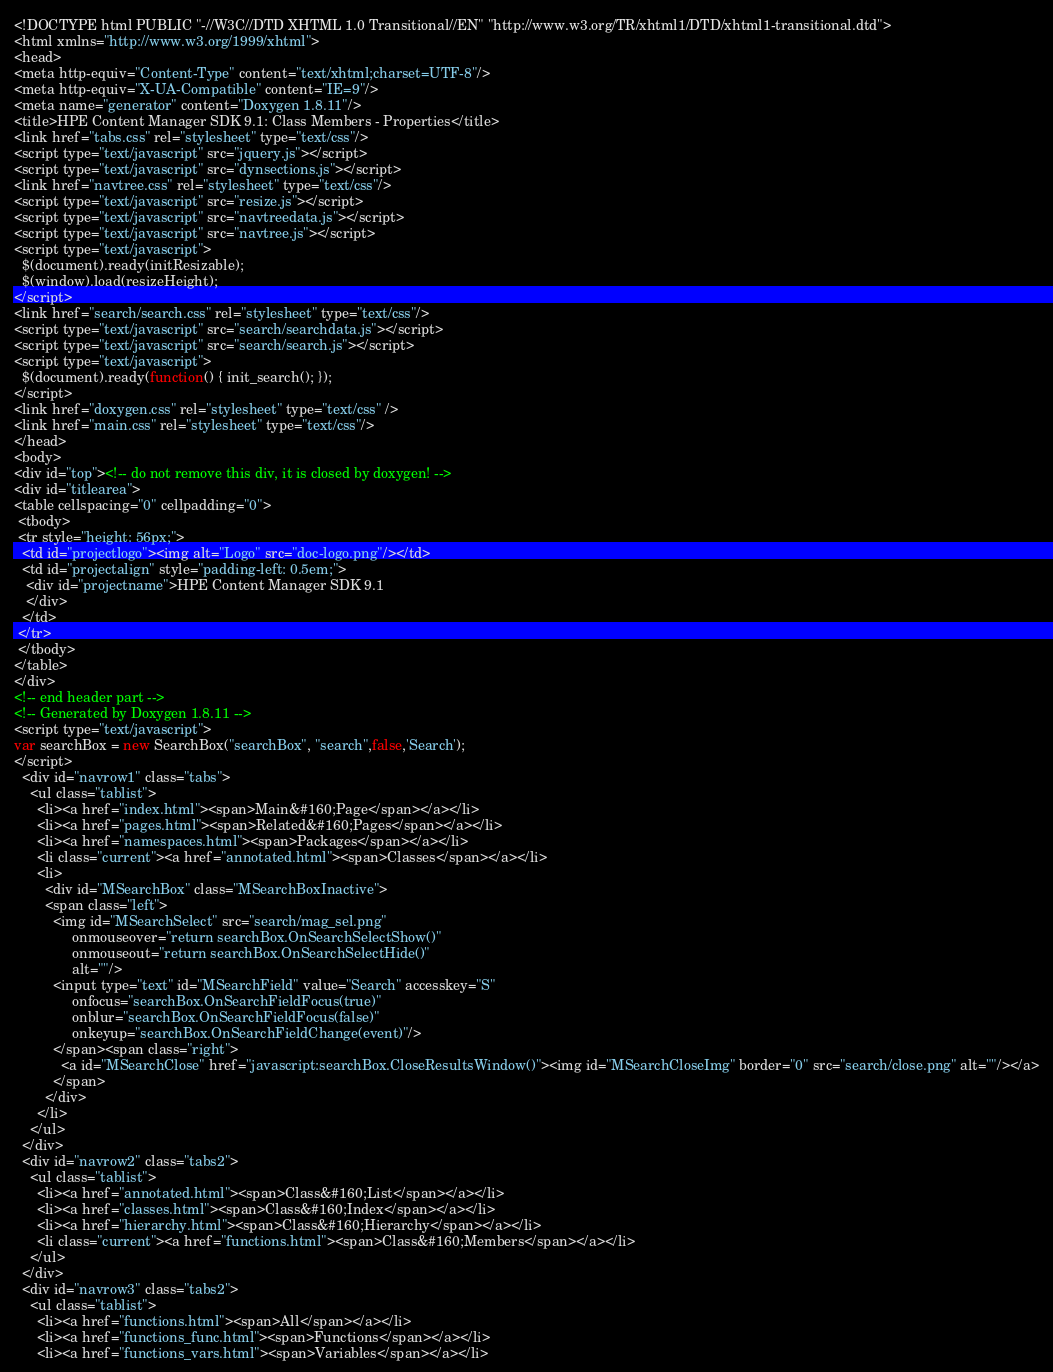Convert code to text. <code><loc_0><loc_0><loc_500><loc_500><_HTML_><!DOCTYPE html PUBLIC "-//W3C//DTD XHTML 1.0 Transitional//EN" "http://www.w3.org/TR/xhtml1/DTD/xhtml1-transitional.dtd">
<html xmlns="http://www.w3.org/1999/xhtml">
<head>
<meta http-equiv="Content-Type" content="text/xhtml;charset=UTF-8"/>
<meta http-equiv="X-UA-Compatible" content="IE=9"/>
<meta name="generator" content="Doxygen 1.8.11"/>
<title>HPE Content Manager SDK 9.1: Class Members - Properties</title>
<link href="tabs.css" rel="stylesheet" type="text/css"/>
<script type="text/javascript" src="jquery.js"></script>
<script type="text/javascript" src="dynsections.js"></script>
<link href="navtree.css" rel="stylesheet" type="text/css"/>
<script type="text/javascript" src="resize.js"></script>
<script type="text/javascript" src="navtreedata.js"></script>
<script type="text/javascript" src="navtree.js"></script>
<script type="text/javascript">
  $(document).ready(initResizable);
  $(window).load(resizeHeight);
</script>
<link href="search/search.css" rel="stylesheet" type="text/css"/>
<script type="text/javascript" src="search/searchdata.js"></script>
<script type="text/javascript" src="search/search.js"></script>
<script type="text/javascript">
  $(document).ready(function() { init_search(); });
</script>
<link href="doxygen.css" rel="stylesheet" type="text/css" />
<link href="main.css" rel="stylesheet" type="text/css"/>
</head>
<body>
<div id="top"><!-- do not remove this div, it is closed by doxygen! -->
<div id="titlearea">
<table cellspacing="0" cellpadding="0">
 <tbody>
 <tr style="height: 56px;">
  <td id="projectlogo"><img alt="Logo" src="doc-logo.png"/></td>
  <td id="projectalign" style="padding-left: 0.5em;">
   <div id="projectname">HPE Content Manager SDK 9.1
   </div>
  </td>
 </tr>
 </tbody>
</table>
</div>
<!-- end header part -->
<!-- Generated by Doxygen 1.8.11 -->
<script type="text/javascript">
var searchBox = new SearchBox("searchBox", "search",false,'Search');
</script>
  <div id="navrow1" class="tabs">
    <ul class="tablist">
      <li><a href="index.html"><span>Main&#160;Page</span></a></li>
      <li><a href="pages.html"><span>Related&#160;Pages</span></a></li>
      <li><a href="namespaces.html"><span>Packages</span></a></li>
      <li class="current"><a href="annotated.html"><span>Classes</span></a></li>
      <li>
        <div id="MSearchBox" class="MSearchBoxInactive">
        <span class="left">
          <img id="MSearchSelect" src="search/mag_sel.png"
               onmouseover="return searchBox.OnSearchSelectShow()"
               onmouseout="return searchBox.OnSearchSelectHide()"
               alt=""/>
          <input type="text" id="MSearchField" value="Search" accesskey="S"
               onfocus="searchBox.OnSearchFieldFocus(true)" 
               onblur="searchBox.OnSearchFieldFocus(false)" 
               onkeyup="searchBox.OnSearchFieldChange(event)"/>
          </span><span class="right">
            <a id="MSearchClose" href="javascript:searchBox.CloseResultsWindow()"><img id="MSearchCloseImg" border="0" src="search/close.png" alt=""/></a>
          </span>
        </div>
      </li>
    </ul>
  </div>
  <div id="navrow2" class="tabs2">
    <ul class="tablist">
      <li><a href="annotated.html"><span>Class&#160;List</span></a></li>
      <li><a href="classes.html"><span>Class&#160;Index</span></a></li>
      <li><a href="hierarchy.html"><span>Class&#160;Hierarchy</span></a></li>
      <li class="current"><a href="functions.html"><span>Class&#160;Members</span></a></li>
    </ul>
  </div>
  <div id="navrow3" class="tabs2">
    <ul class="tablist">
      <li><a href="functions.html"><span>All</span></a></li>
      <li><a href="functions_func.html"><span>Functions</span></a></li>
      <li><a href="functions_vars.html"><span>Variables</span></a></li></code> 